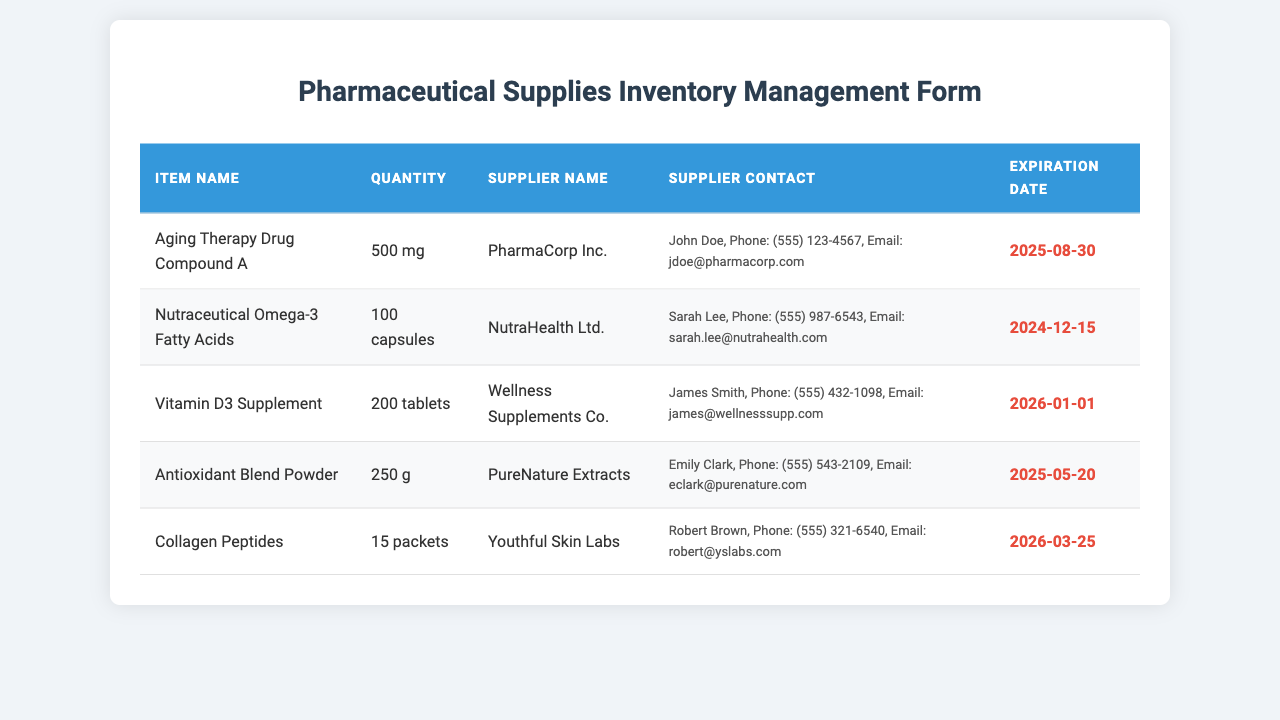What is the quantity of Aging Therapy Drug Compound A? The quantity is stated in grams, specifically 500 mg.
Answer: 500 mg When does the expiration date of Nutraceutical Omega-3 Fatty Acids occur? The expiration date is provided as a specific date in the document, which is December 15, 2024.
Answer: 2024-12-15 Who is the supplier for the Collagen Peptides? The supplier's name is mentioned in the document, which is Youthful Skin Labs.
Answer: Youthful Skin Labs What is the supplier contact for Antioxidant Blend Powder? The supplier contact information includes the name, phone number, and email of the contact person, Emily Clark.
Answer: Emily Clark, Phone: (555) 543-2109, Email: eclark@purenature.com How many total items listed have expiration dates beyond 2025? By reviewing the expiration dates, we find they go beyond 2025 for two items: Vitamin D3 Supplement and Collagen Peptides.
Answer: 2 